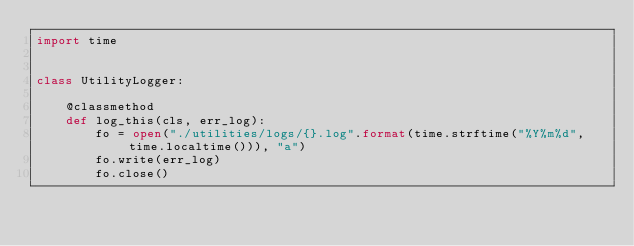Convert code to text. <code><loc_0><loc_0><loc_500><loc_500><_Python_>import time


class UtilityLogger:

    @classmethod
    def log_this(cls, err_log):
        fo = open("./utilities/logs/{}.log".format(time.strftime("%Y%m%d", time.localtime())), "a")
        fo.write(err_log)
        fo.close()
</code> 